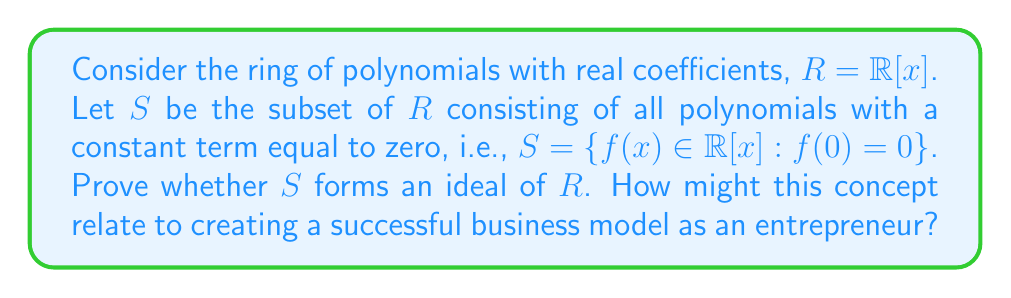Can you solve this math problem? To prove whether $S$ forms an ideal of $R$, we need to verify three conditions:

1. $S$ is non-empty
2. $S$ is closed under addition
3. For any $s \in S$ and $r \in R$, both $rs$ and $sr$ are in $S$

Let's verify each condition:

1. Non-empty: 
   The polynomial $f(x) = x$ is in $S$ since $f(0) = 0$. Thus, $S$ is non-empty.

2. Closure under addition:
   Let $f(x), g(x) \in S$. Then:
   $$f(x) = a_1x + a_2x^2 + ... + a_nx^n$$
   $$g(x) = b_1x + b_2x^2 + ... + b_mx^m$$
   Their sum is:
   $$(f+g)(x) = (a_1+b_1)x + (a_2+b_2)x^2 + ...$$
   Clearly, $(f+g)(0) = 0$, so $f(x) + g(x) \in S$.

3. Closure under multiplication by ring elements:
   Let $f(x) \in S$ and $r(x) \in R$. Then:
   $$f(x) = a_1x + a_2x^2 + ... + a_nx^n$$
   $$r(x) = r_0 + r_1x + r_2x^2 + ... + r_mx^m$$
   Their product is:
   $$(rf)(x) = r_0(a_1x + a_2x^2 + ... + a_nx^n) + r_1x(a_1x + a_2x^2 + ... + a_nx^n) + ...$$
   $$(rf)(0) = 0$$
   Thus, $rf \in S$. Similarly, $fr \in S$.

Therefore, $S$ satisfies all three conditions and forms an ideal of $R$.

This concept relates to entrepreneurship as it demonstrates the importance of identifying and maintaining consistent properties within a business model. Just as all elements in the ideal $S$ share the property of having a zero constant term, a successful business model should have core principles or features that remain consistent across all aspects of the operation. This consistency can lead to a cohesive brand identity and streamlined business processes.
Answer: $S$ forms an ideal of $R = \mathbb{R}[x]$. The subset $S = \{f(x) \in \mathbb{R}[x] : f(0) = 0\}$ satisfies all three conditions for an ideal: it is non-empty, closed under addition, and closed under multiplication by any element of the ring. 